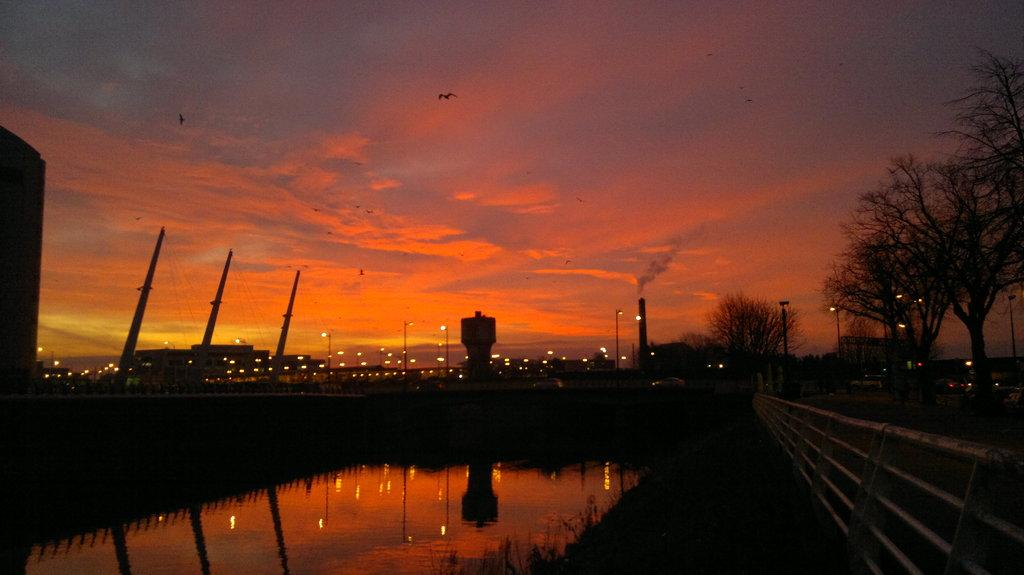Where was the image taken? The image was clicked outside. What can be seen on the right side of the image? There are trees on the right side of the image. What structures are visible in the middle of the image? There are buildings in the middle of the image. What is visible at the top of the image? The sky is visible at the top of the image. What is present at the bottom of the image? There is water at the bottom of the image. What type of stamp can be seen on the crate in the image? There is no crate or stamp present in the image. How many family members are visible in the image? There is no family present in the image; it features trees, buildings, sky, and water. 